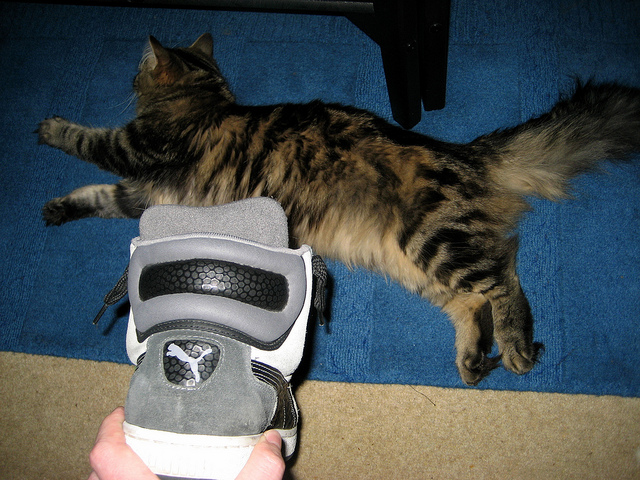<image>How long is the fur of the cat? I don't know how long is the fur of the cat. It could be long or medium. How long is the fur of the cat? I don't know how long the fur of the cat is. It can be long or medium. 